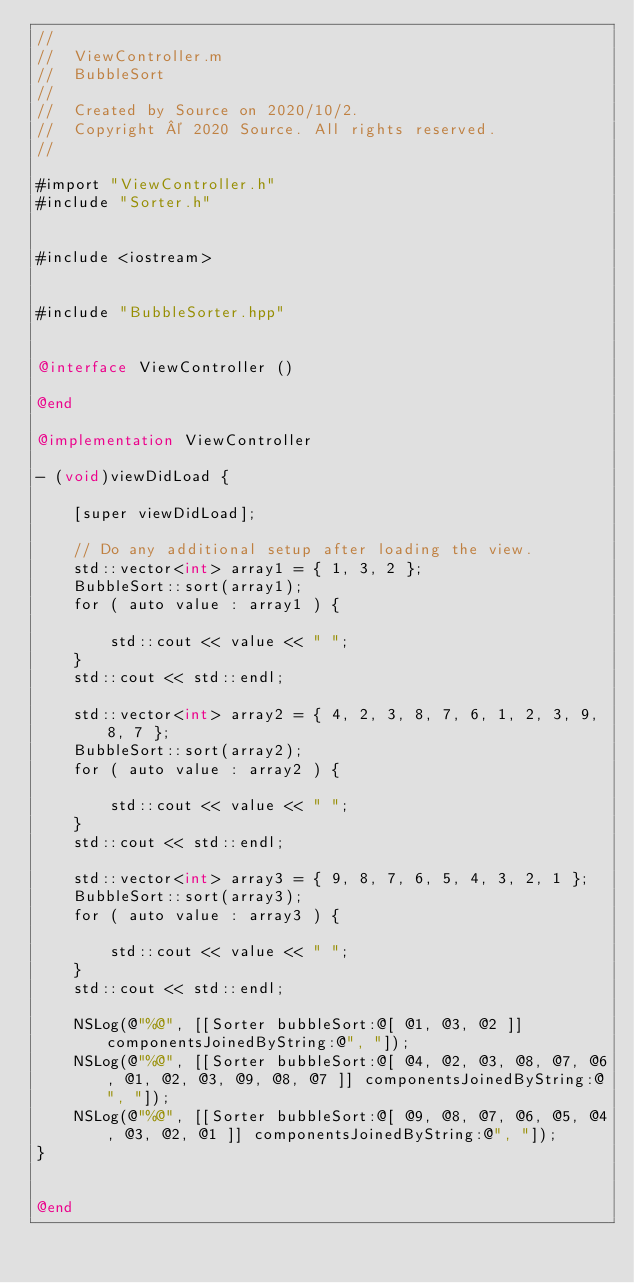Convert code to text. <code><loc_0><loc_0><loc_500><loc_500><_ObjectiveC_>//
//  ViewController.m
//  BubbleSort
//
//  Created by Source on 2020/10/2.
//  Copyright © 2020 Source. All rights reserved.
//

#import "ViewController.h"
#include "Sorter.h"


#include <iostream>


#include "BubbleSorter.hpp"


@interface ViewController ()

@end

@implementation ViewController

- (void)viewDidLoad {
    
    [super viewDidLoad];
    
    // Do any additional setup after loading the view.
    std::vector<int> array1 = { 1, 3, 2 };
    BubbleSort::sort(array1);
    for ( auto value : array1 ) {
        
        std::cout << value << " ";
    }
    std::cout << std::endl;
    
    std::vector<int> array2 = { 4, 2, 3, 8, 7, 6, 1, 2, 3, 9, 8, 7 };
    BubbleSort::sort(array2);
    for ( auto value : array2 ) {
        
        std::cout << value << " ";
    }
    std::cout << std::endl;
    
    std::vector<int> array3 = { 9, 8, 7, 6, 5, 4, 3, 2, 1 };
    BubbleSort::sort(array3);
    for ( auto value : array3 ) {
        
        std::cout << value << " ";
    }
    std::cout << std::endl;
    
    NSLog(@"%@", [[Sorter bubbleSort:@[ @1, @3, @2 ]] componentsJoinedByString:@", "]);
    NSLog(@"%@", [[Sorter bubbleSort:@[ @4, @2, @3, @8, @7, @6, @1, @2, @3, @9, @8, @7 ]] componentsJoinedByString:@", "]);
    NSLog(@"%@", [[Sorter bubbleSort:@[ @9, @8, @7, @6, @5, @4, @3, @2, @1 ]] componentsJoinedByString:@", "]);
}


@end
</code> 